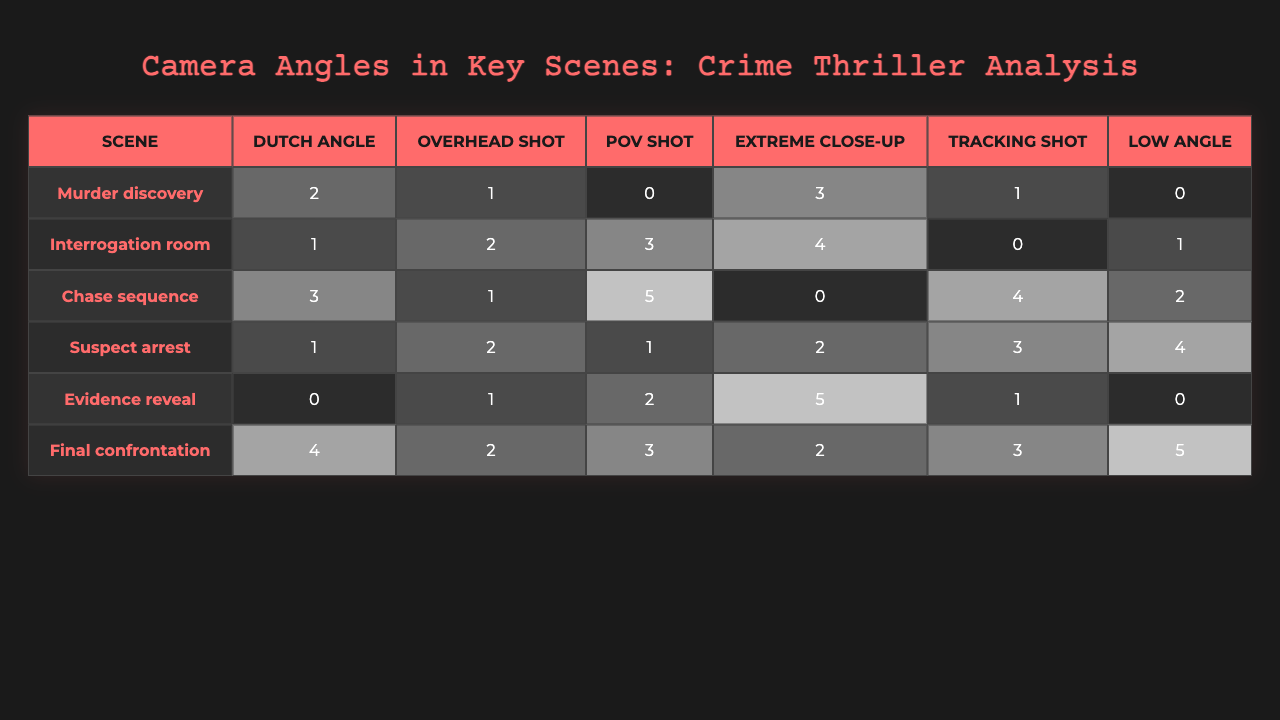What is the highest number of camera angles used in the "Chase sequence"? In the "Chase sequence" row, the highest value of camera angles is 5, which corresponds to the POV shot.
Answer: 5 How many times was a Dutch angle used in the "Final confrontation"? The "Final confrontation" row shows that the Dutch angle was used 4 times.
Answer: 4 What is the average number of Extreme close-ups across all scenes? Summing the Extreme close-up values gives (3 + 4 + 0 + 2 + 5 + 2) = 16. There are 6 scenes, so the average is 16/6 ≈ 2.67.
Answer: Approximately 2.67 In which scene was the low angle used the most? By checking the low angle column, the maximum value of 5 appears in the "Final confrontation."
Answer: Final confrontation How many more POV shots were used in the "Chase sequence" than in the "Suspect arrest"? The "Chase sequence" has 5 POV shots and the "Suspect arrest" has 1, so the difference is 5 - 1 = 4.
Answer: 4 True or False: The "Evidence reveal" scene has more Extreme close-ups than the "Murder discovery." "Evidence reveal" has 5 Extreme close-ups, while "Murder discovery" has 3, making the statement true.
Answer: True Which scene features the least use of Tracking shots? The "Interrogation room" has 0 Tracking shots, which is the least among all scenes.
Answer: Interrogation room What is the total number of Dutch angles used across all scenes? Adding the Dutch angles gives (2 + 1 + 3 + 1 + 0 + 4) = 11.
Answer: 11 Which camera angle appears most frequently across the "Suspect arrest" and "Final confrontation"? In "Suspect arrest", the highest count is 4 (Low angle), while in "Final confrontation", it is also 5 (Low angle). Thus, Low angle is the most frequent when considering both scenes.
Answer: Low angle Are there any scenes where the Overhead shot was not used? "Murder discovery" and "Evidence reveal" have the Overhead shot used only once, but it is not absent. All scenes have at least 1 overhead shot used.
Answer: No 